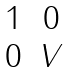<formula> <loc_0><loc_0><loc_500><loc_500>\begin{matrix} 1 & 0 \\ 0 & V \end{matrix}</formula> 